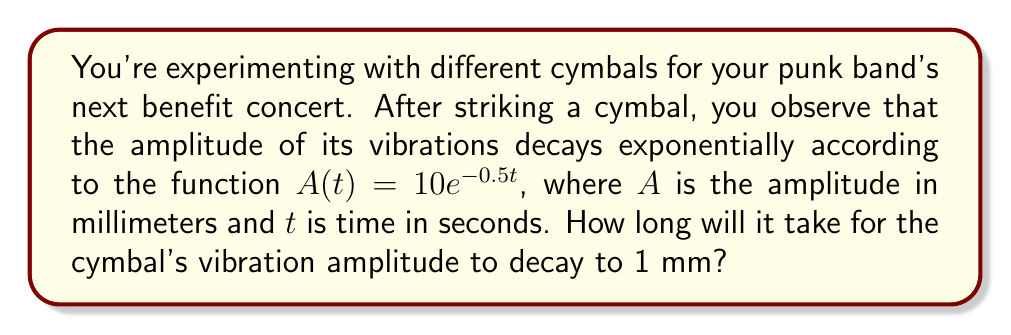Provide a solution to this math problem. Let's approach this step-by-step:

1) We're given the decay function: $A(t) = 10e^{-0.5t}$

2) We want to find $t$ when $A(t) = 1$ mm. So, let's set up the equation:

   $1 = 10e^{-0.5t}$

3) Divide both sides by 10:

   $\frac{1}{10} = e^{-0.5t}$

4) Take the natural logarithm of both sides:

   $\ln(\frac{1}{10}) = \ln(e^{-0.5t})$

5) Simplify the right side using the properties of logarithms:

   $\ln(\frac{1}{10}) = -0.5t$

6) Solve for $t$:

   $t = -\frac{2\ln(\frac{1}{10})}{1} = -2\ln(\frac{1}{10})$

7) Simplify:

   $t = -2(-2.30259) = 4.60518$

Therefore, it will take approximately 4.61 seconds for the cymbal's vibration amplitude to decay to 1 mm.
Answer: 4.61 seconds 